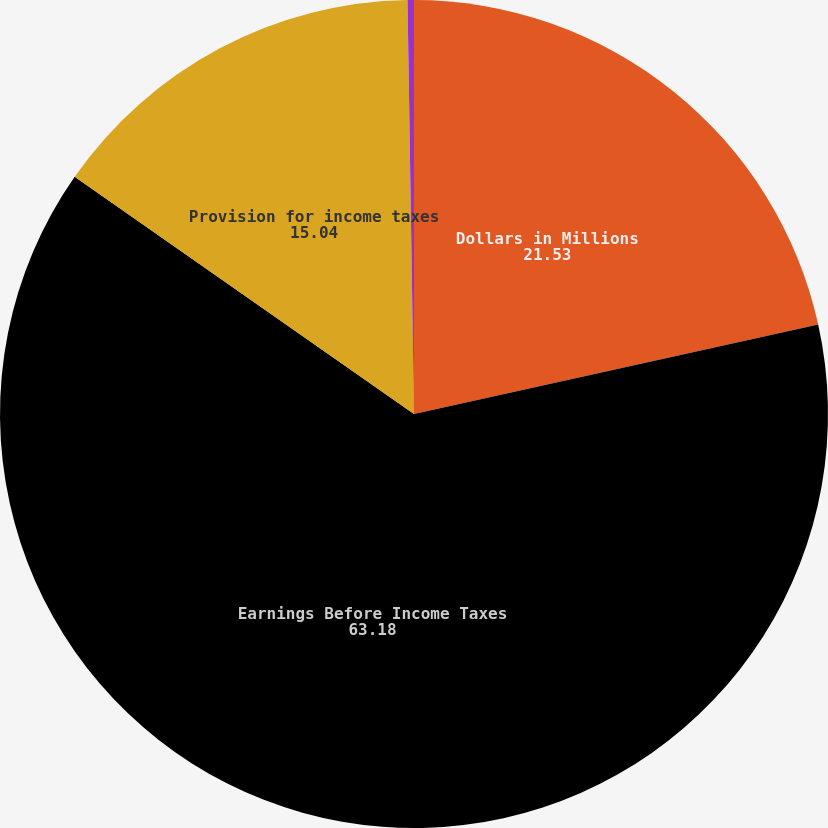<chart> <loc_0><loc_0><loc_500><loc_500><pie_chart><fcel>Dollars in Millions<fcel>Earnings Before Income Taxes<fcel>Provision for income taxes<fcel>Effective tax rate<nl><fcel>21.53%<fcel>63.18%<fcel>15.04%<fcel>0.25%<nl></chart> 